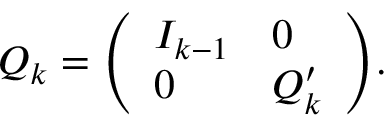Convert formula to latex. <formula><loc_0><loc_0><loc_500><loc_500>Q _ { k } = { \left ( \begin{array} { l l } { I _ { k - 1 } } & { 0 } \\ { 0 } & { Q _ { k } ^ { \prime } } \end{array} \right ) } .</formula> 